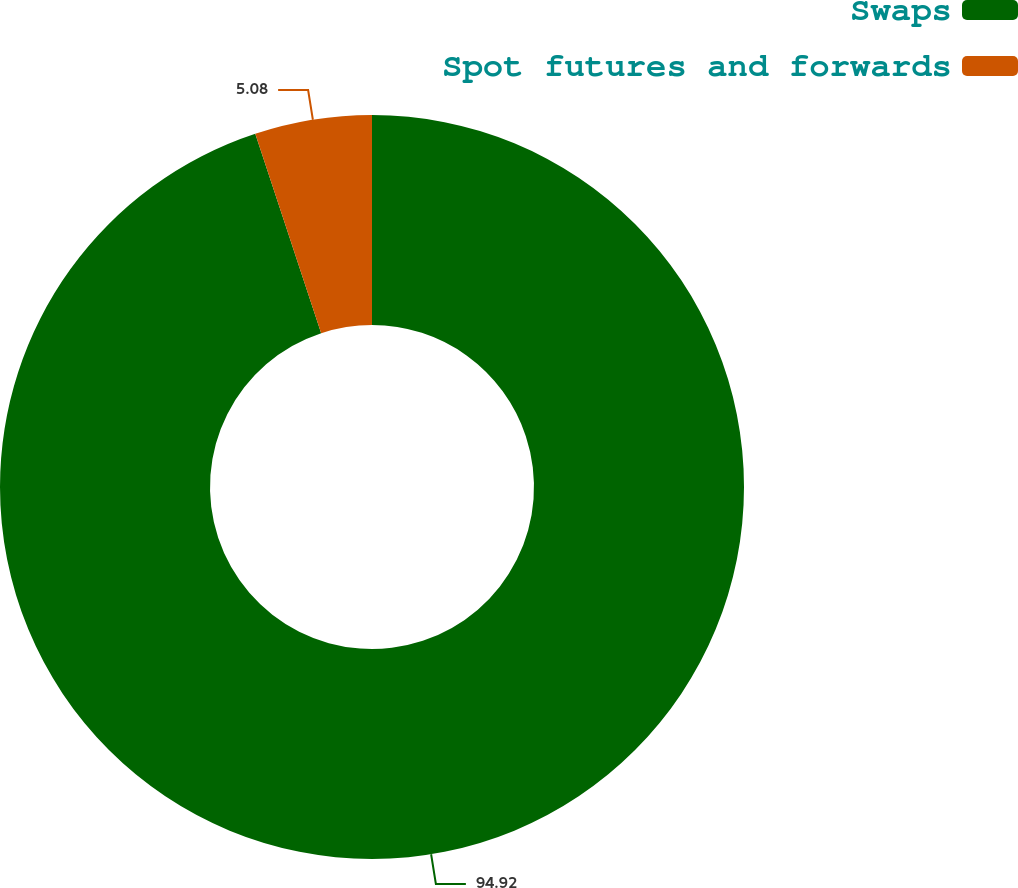<chart> <loc_0><loc_0><loc_500><loc_500><pie_chart><fcel>Swaps<fcel>Spot futures and forwards<nl><fcel>94.92%<fcel>5.08%<nl></chart> 